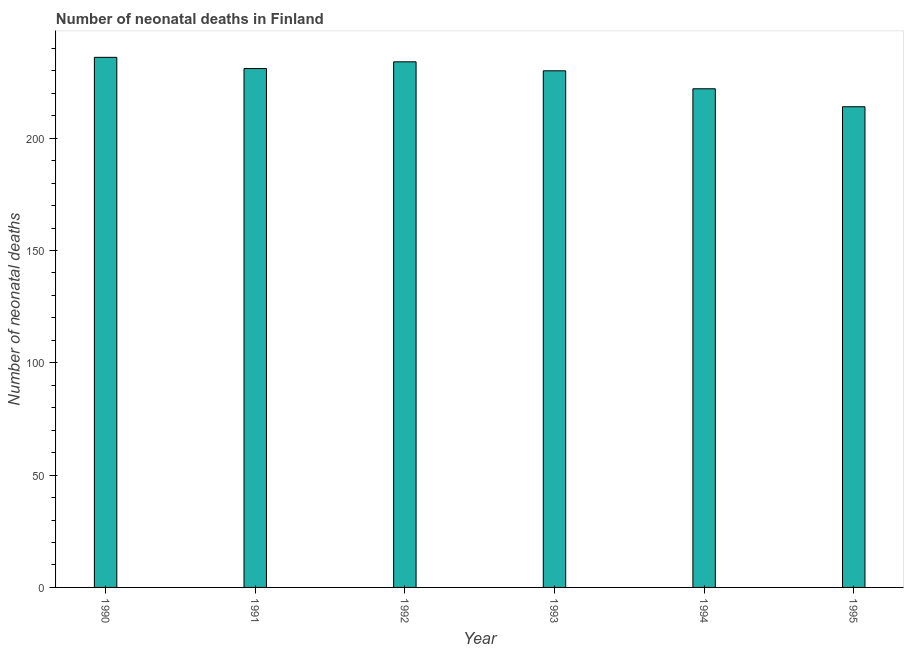Does the graph contain any zero values?
Make the answer very short. No. What is the title of the graph?
Offer a terse response. Number of neonatal deaths in Finland. What is the label or title of the Y-axis?
Make the answer very short. Number of neonatal deaths. What is the number of neonatal deaths in 1993?
Your answer should be compact. 230. Across all years, what is the maximum number of neonatal deaths?
Ensure brevity in your answer.  236. Across all years, what is the minimum number of neonatal deaths?
Your answer should be very brief. 214. In which year was the number of neonatal deaths minimum?
Make the answer very short. 1995. What is the sum of the number of neonatal deaths?
Your answer should be compact. 1367. What is the average number of neonatal deaths per year?
Ensure brevity in your answer.  227. What is the median number of neonatal deaths?
Give a very brief answer. 230.5. In how many years, is the number of neonatal deaths greater than 70 ?
Your answer should be very brief. 6. Do a majority of the years between 1992 and 1995 (inclusive) have number of neonatal deaths greater than 190 ?
Your answer should be very brief. Yes. What is the ratio of the number of neonatal deaths in 1990 to that in 1992?
Provide a short and direct response. 1.01. Is the sum of the number of neonatal deaths in 1991 and 1995 greater than the maximum number of neonatal deaths across all years?
Provide a short and direct response. Yes. What is the difference between the highest and the lowest number of neonatal deaths?
Your answer should be compact. 22. How many bars are there?
Give a very brief answer. 6. Are all the bars in the graph horizontal?
Your answer should be compact. No. What is the difference between two consecutive major ticks on the Y-axis?
Ensure brevity in your answer.  50. Are the values on the major ticks of Y-axis written in scientific E-notation?
Offer a terse response. No. What is the Number of neonatal deaths in 1990?
Make the answer very short. 236. What is the Number of neonatal deaths of 1991?
Offer a terse response. 231. What is the Number of neonatal deaths of 1992?
Your answer should be very brief. 234. What is the Number of neonatal deaths of 1993?
Make the answer very short. 230. What is the Number of neonatal deaths in 1994?
Provide a succinct answer. 222. What is the Number of neonatal deaths of 1995?
Your answer should be very brief. 214. What is the difference between the Number of neonatal deaths in 1990 and 1991?
Provide a short and direct response. 5. What is the difference between the Number of neonatal deaths in 1990 and 1992?
Your answer should be very brief. 2. What is the difference between the Number of neonatal deaths in 1990 and 1995?
Give a very brief answer. 22. What is the difference between the Number of neonatal deaths in 1991 and 1992?
Keep it short and to the point. -3. What is the difference between the Number of neonatal deaths in 1991 and 1993?
Your answer should be very brief. 1. What is the difference between the Number of neonatal deaths in 1991 and 1994?
Make the answer very short. 9. What is the difference between the Number of neonatal deaths in 1991 and 1995?
Offer a terse response. 17. What is the difference between the Number of neonatal deaths in 1992 and 1993?
Offer a terse response. 4. What is the difference between the Number of neonatal deaths in 1992 and 1994?
Your response must be concise. 12. What is the ratio of the Number of neonatal deaths in 1990 to that in 1991?
Offer a very short reply. 1.02. What is the ratio of the Number of neonatal deaths in 1990 to that in 1992?
Provide a short and direct response. 1.01. What is the ratio of the Number of neonatal deaths in 1990 to that in 1994?
Offer a very short reply. 1.06. What is the ratio of the Number of neonatal deaths in 1990 to that in 1995?
Offer a very short reply. 1.1. What is the ratio of the Number of neonatal deaths in 1991 to that in 1992?
Give a very brief answer. 0.99. What is the ratio of the Number of neonatal deaths in 1991 to that in 1994?
Provide a short and direct response. 1.04. What is the ratio of the Number of neonatal deaths in 1991 to that in 1995?
Offer a very short reply. 1.08. What is the ratio of the Number of neonatal deaths in 1992 to that in 1994?
Your answer should be very brief. 1.05. What is the ratio of the Number of neonatal deaths in 1992 to that in 1995?
Ensure brevity in your answer.  1.09. What is the ratio of the Number of neonatal deaths in 1993 to that in 1994?
Ensure brevity in your answer.  1.04. What is the ratio of the Number of neonatal deaths in 1993 to that in 1995?
Make the answer very short. 1.07. What is the ratio of the Number of neonatal deaths in 1994 to that in 1995?
Give a very brief answer. 1.04. 